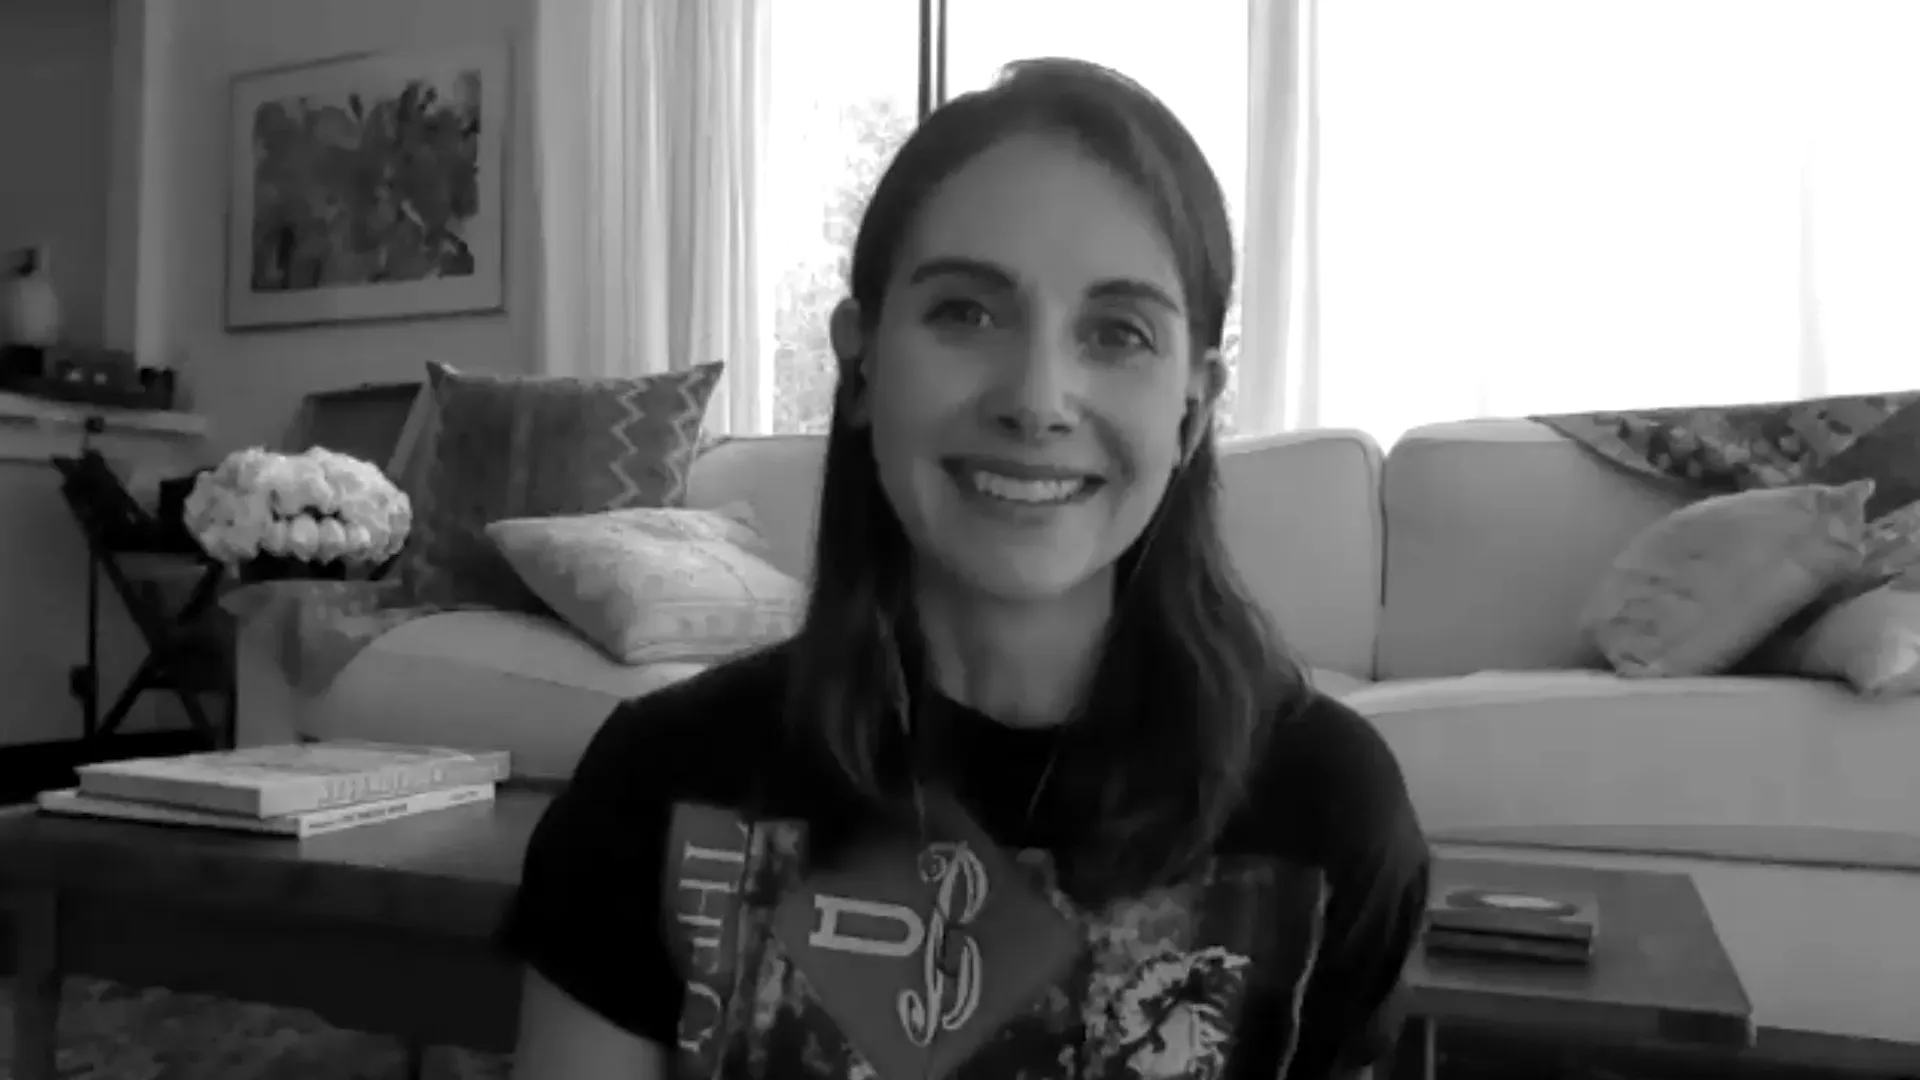What do you think the woman is thinking about while smiling? The woman’s warm smile suggests she is perhaps thinking about a pleasant moment or an upcoming joyful event. She could be reminiscing about fond memories with loved ones, feeling satisfied with a recently completed personal project, or simply enjoying the peaceful ambiance of her cozy living space. The natural light and comfortable setting around her might also be contributing to her light-hearted and relaxed demeanor. 